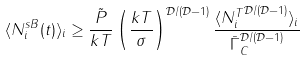<formula> <loc_0><loc_0><loc_500><loc_500>\langle N _ { i } ^ { s B } ( t ) \rangle _ { i } \geq \frac { \tilde { P } } { k T } \left ( \frac { k T } { \sigma } \right ) ^ { \mathcal { D } / ( \mathcal { D } - 1 ) } \frac { \langle { N _ { i } ^ { T } } ^ { \mathcal { D } / ( \mathcal { D } - 1 ) } \rangle _ { i } } { \bar { \Gamma } _ { C } ^ { \mathcal { D } / ( \mathcal { D } - 1 ) } }</formula> 